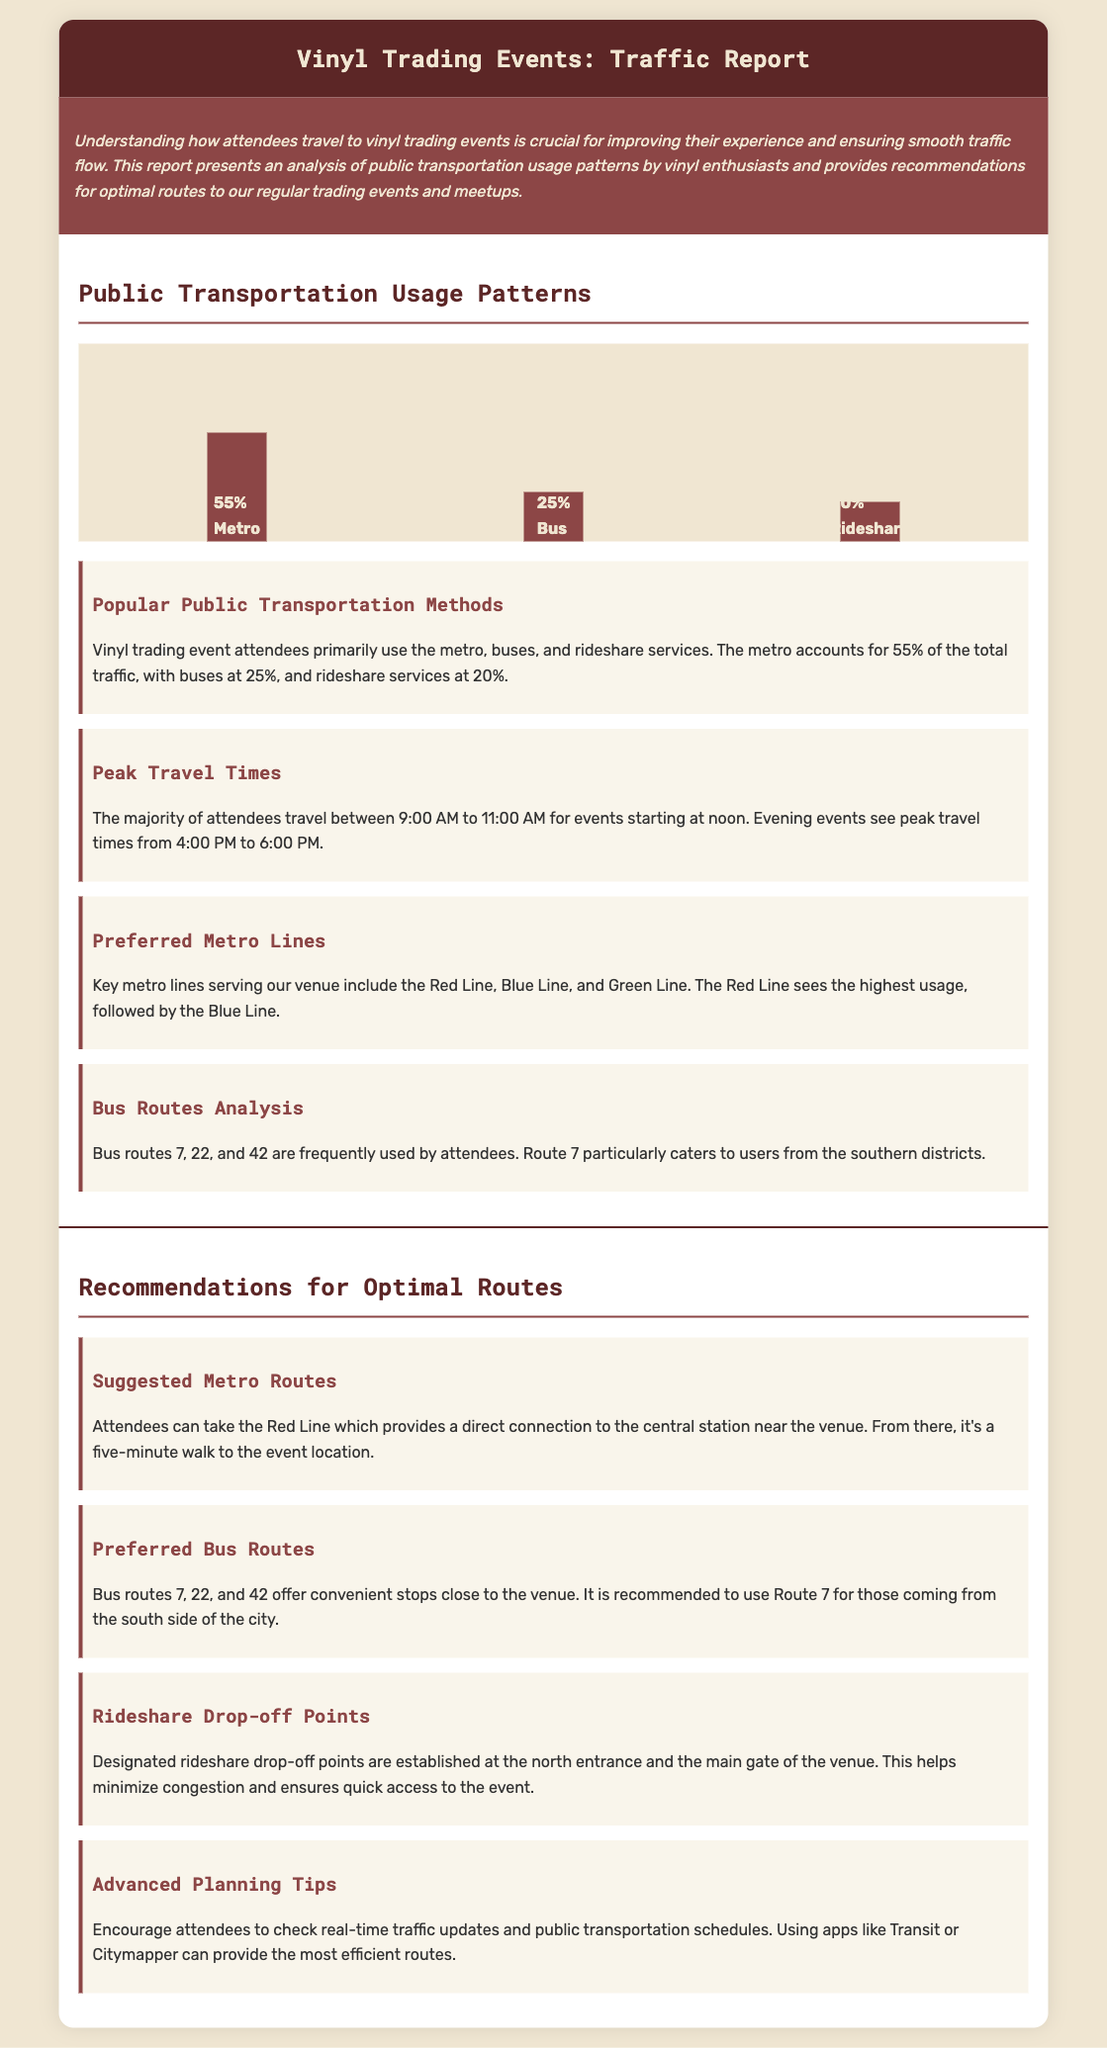What percentage of attendees use the metro? The document states that 55% of attendees primarily use the metro for their travel.
Answer: 55% What time do majority of attendees travel for noon events? The report indicates that most attendees travel between 9:00 AM to 11:00 AM for events starting at noon.
Answer: 9:00 AM to 11:00 AM Which bus routes are frequently used by attendees? The document lists bus routes 7, 22, and 42 as frequently used by attendees.
Answer: 7, 22, and 42 What is the recommended metro line for reaching the venue? It is suggested that attendees take the Red Line, which provides a direct connection to the central station near the venue.
Answer: Red Line What is the primary mode of transport for vinyl event attendees? The report indicates that the primary mode of transport is the metro, accounting for 55% of total traffic.
Answer: Metro How much of the total traffic is accounted for by rideshare services? Rideshare services account for 20% of the total traffic as mentioned in the document.
Answer: 20% What are the designated rideshare drop-off points? The document mentions that designated rideshare drop-off points are at the north entrance and the main gate of the venue.
Answer: North entrance and main gate What should attendees check for advanced planning? Attendees are encouraged to check real-time traffic updates and public transportation schedules.
Answer: Real-time traffic updates Which metro line sees the highest usage? The report indicates that the Red Line sees the highest usage among the preferred metro lines.
Answer: Red Line 